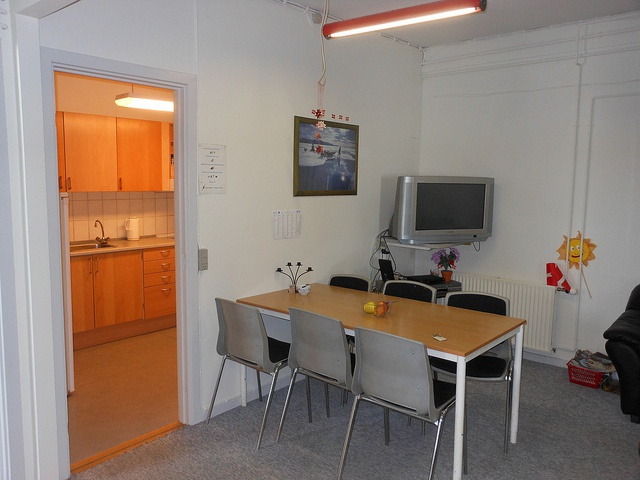Describe the objects in this image and their specific colors. I can see dining table in darkgray, brown, gray, and black tones, chair in darkgray, gray, and black tones, tv in darkgray, black, and gray tones, chair in darkgray, gray, and black tones, and chair in darkgray, gray, and black tones in this image. 